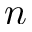Convert formula to latex. <formula><loc_0><loc_0><loc_500><loc_500>n</formula> 